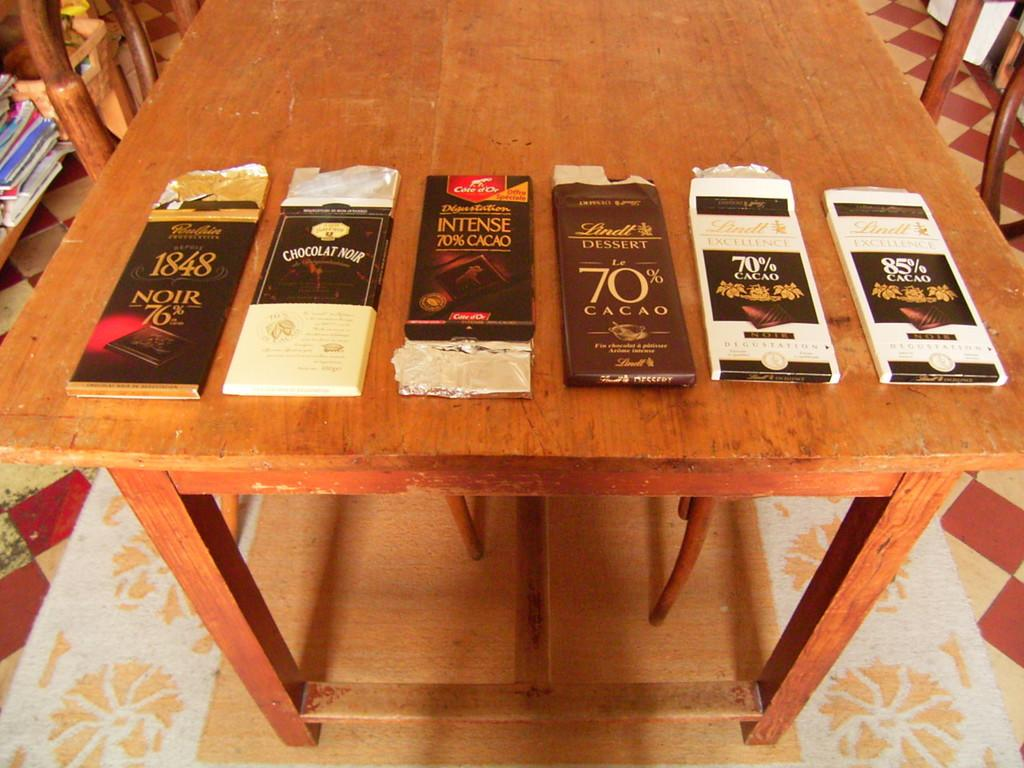<image>
Create a compact narrative representing the image presented. A wood table displays six large bars of chocolate Noir. 